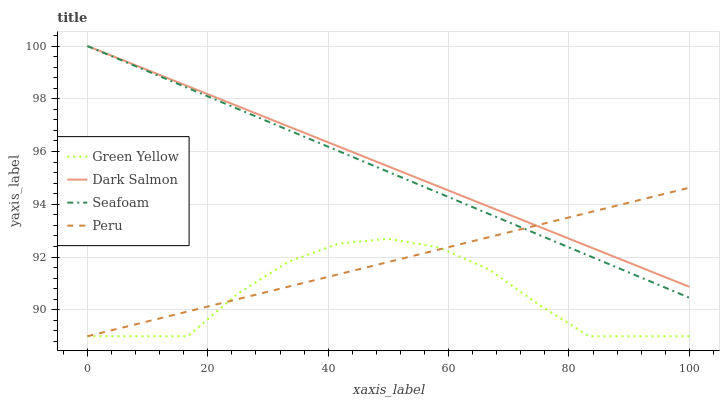Does Green Yellow have the minimum area under the curve?
Answer yes or no. Yes. Does Dark Salmon have the maximum area under the curve?
Answer yes or no. Yes. Does Peru have the minimum area under the curve?
Answer yes or no. No. Does Peru have the maximum area under the curve?
Answer yes or no. No. Is Peru the smoothest?
Answer yes or no. Yes. Is Green Yellow the roughest?
Answer yes or no. Yes. Is Dark Salmon the smoothest?
Answer yes or no. No. Is Dark Salmon the roughest?
Answer yes or no. No. Does Green Yellow have the lowest value?
Answer yes or no. Yes. Does Dark Salmon have the lowest value?
Answer yes or no. No. Does Seafoam have the highest value?
Answer yes or no. Yes. Does Peru have the highest value?
Answer yes or no. No. Is Green Yellow less than Dark Salmon?
Answer yes or no. Yes. Is Dark Salmon greater than Green Yellow?
Answer yes or no. Yes. Does Peru intersect Seafoam?
Answer yes or no. Yes. Is Peru less than Seafoam?
Answer yes or no. No. Is Peru greater than Seafoam?
Answer yes or no. No. Does Green Yellow intersect Dark Salmon?
Answer yes or no. No. 